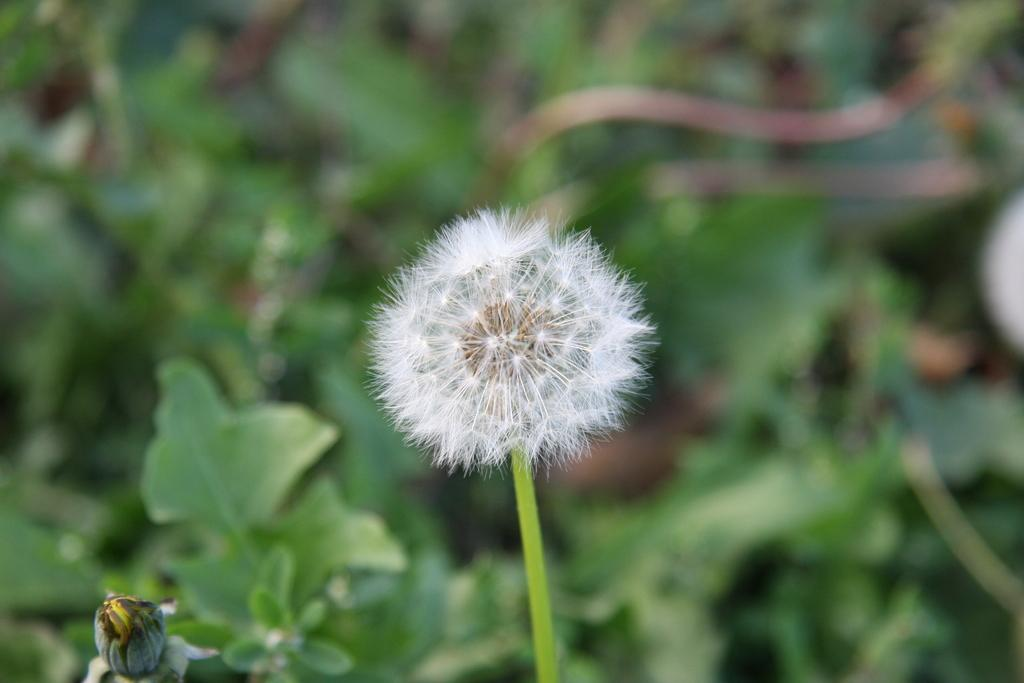What is the main subject of the picture? There is a flower in the picture. How would you describe the background of the picture? The background of the picture is blurred. What else can be seen in the background of the picture besides the blurred area? There are plants visible in the background of the picture. How many eyes can be seen on the flower in the image? There are no eyes visible on the flower in the image, as flowers do not have eyes. What type of fruit is present in the basket next to the flower? There is no basket or fruit present in the image; it only features a flower and a blurred background with plants. 